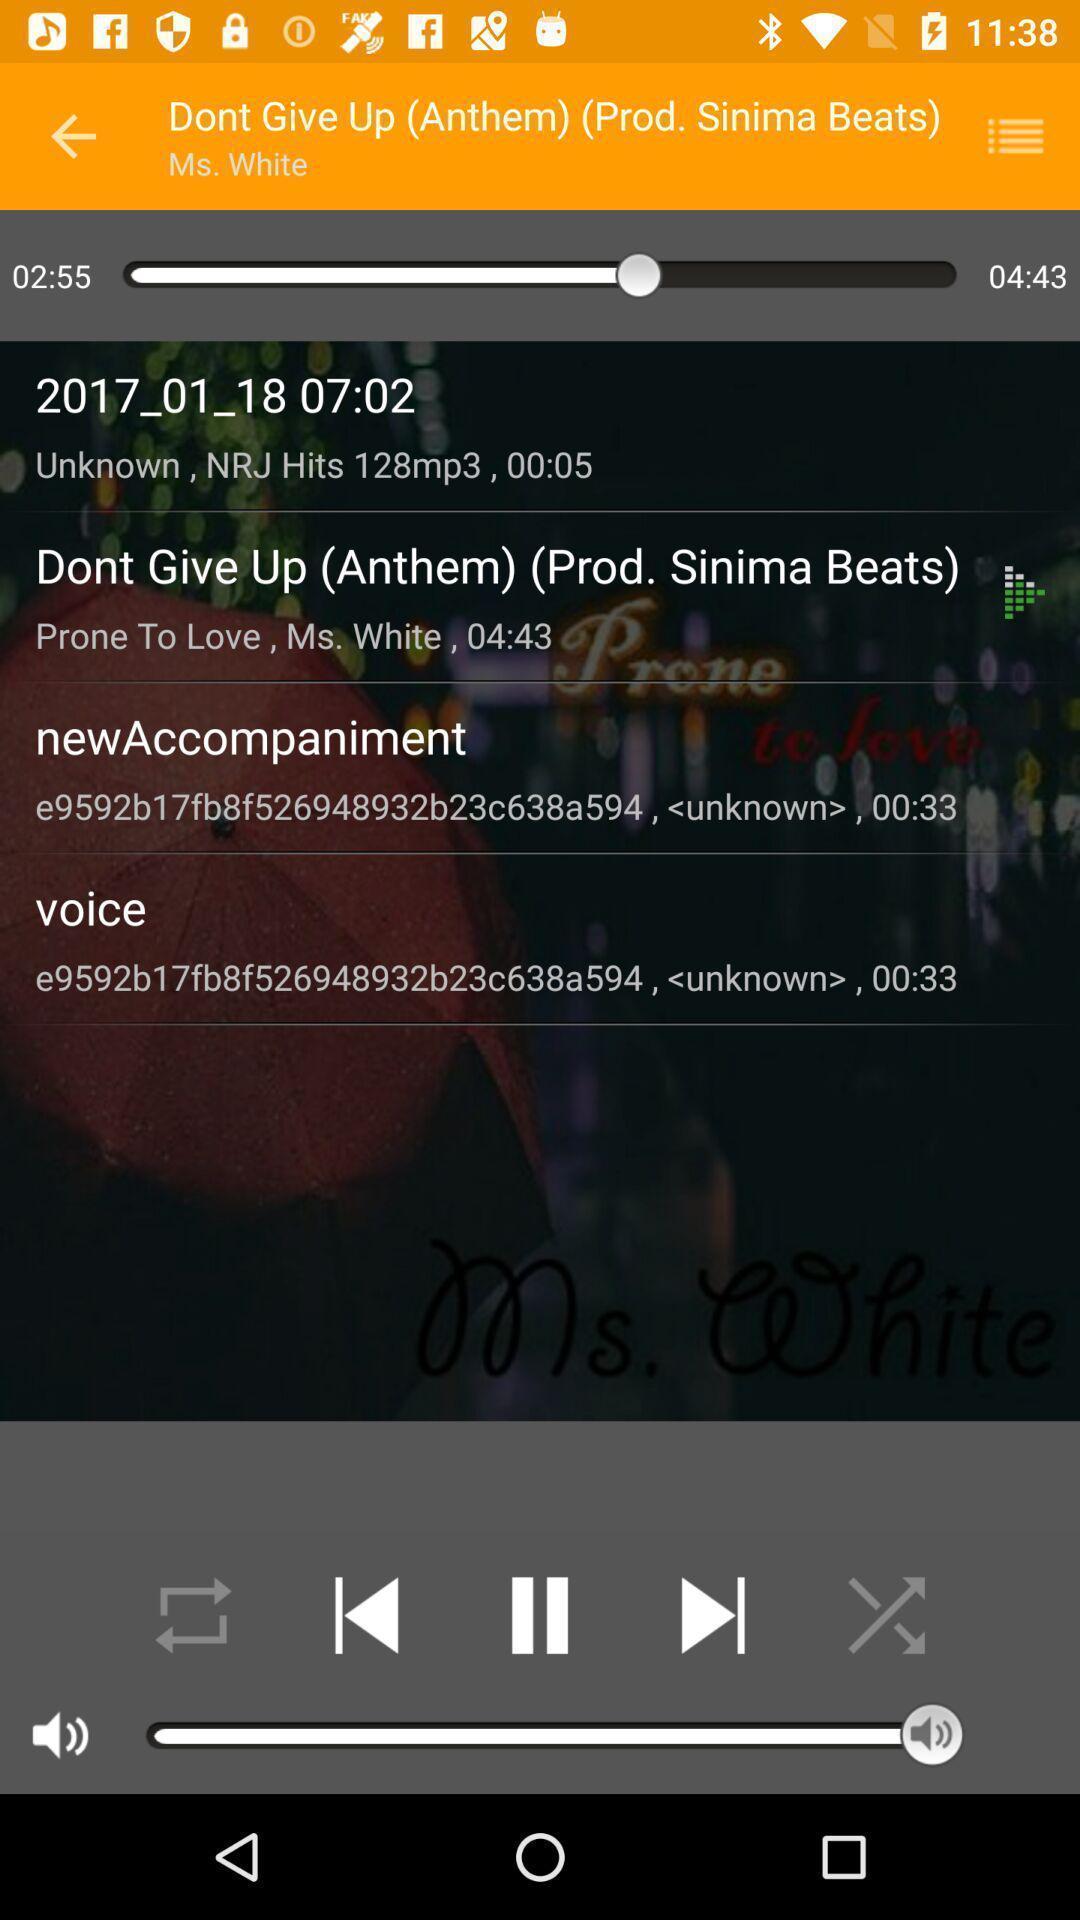What can you discern from this picture? Screen displaying multiple controls and information in a music application. 